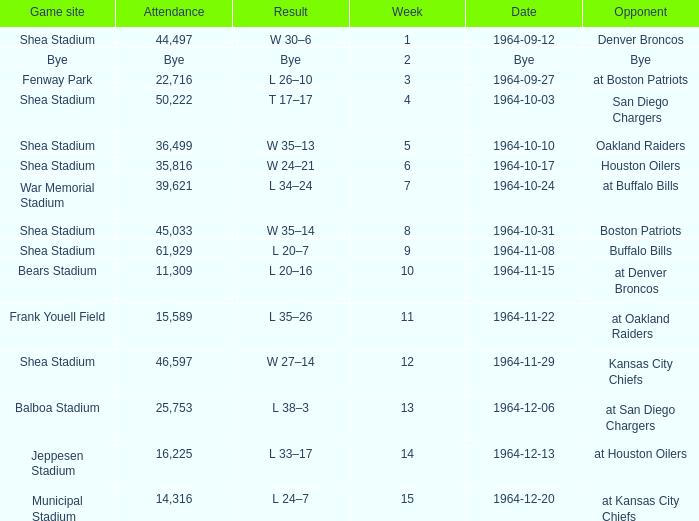At which location did the jets play a game with a crowd of 11,309 people? Bears Stadium. 